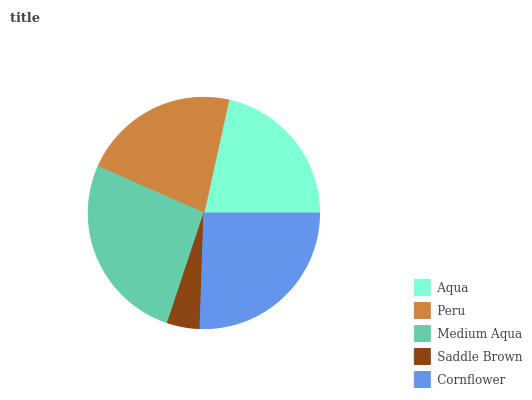Is Saddle Brown the minimum?
Answer yes or no. Yes. Is Medium Aqua the maximum?
Answer yes or no. Yes. Is Peru the minimum?
Answer yes or no. No. Is Peru the maximum?
Answer yes or no. No. Is Peru greater than Aqua?
Answer yes or no. Yes. Is Aqua less than Peru?
Answer yes or no. Yes. Is Aqua greater than Peru?
Answer yes or no. No. Is Peru less than Aqua?
Answer yes or no. No. Is Peru the high median?
Answer yes or no. Yes. Is Peru the low median?
Answer yes or no. Yes. Is Aqua the high median?
Answer yes or no. No. Is Saddle Brown the low median?
Answer yes or no. No. 